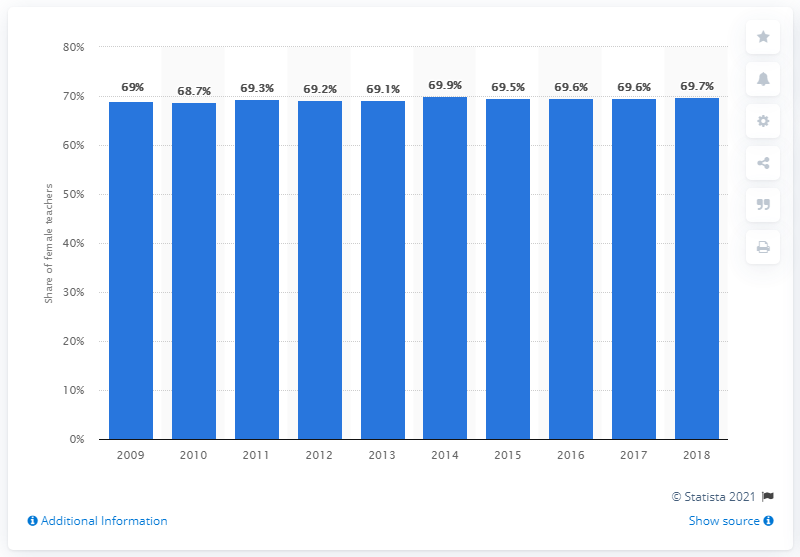Highlight a few significant elements in this photo. In 2018, the percentage of female primary education teachers in Malaysia was 69.7%. 